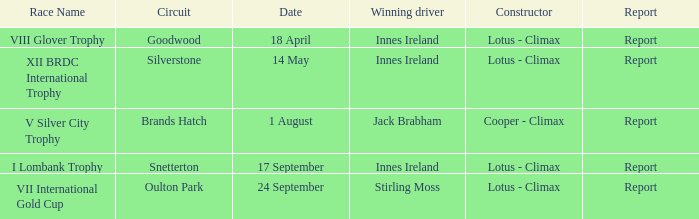What circuit did Innes Ireland win at for the I lombank trophy? Snetterton. 